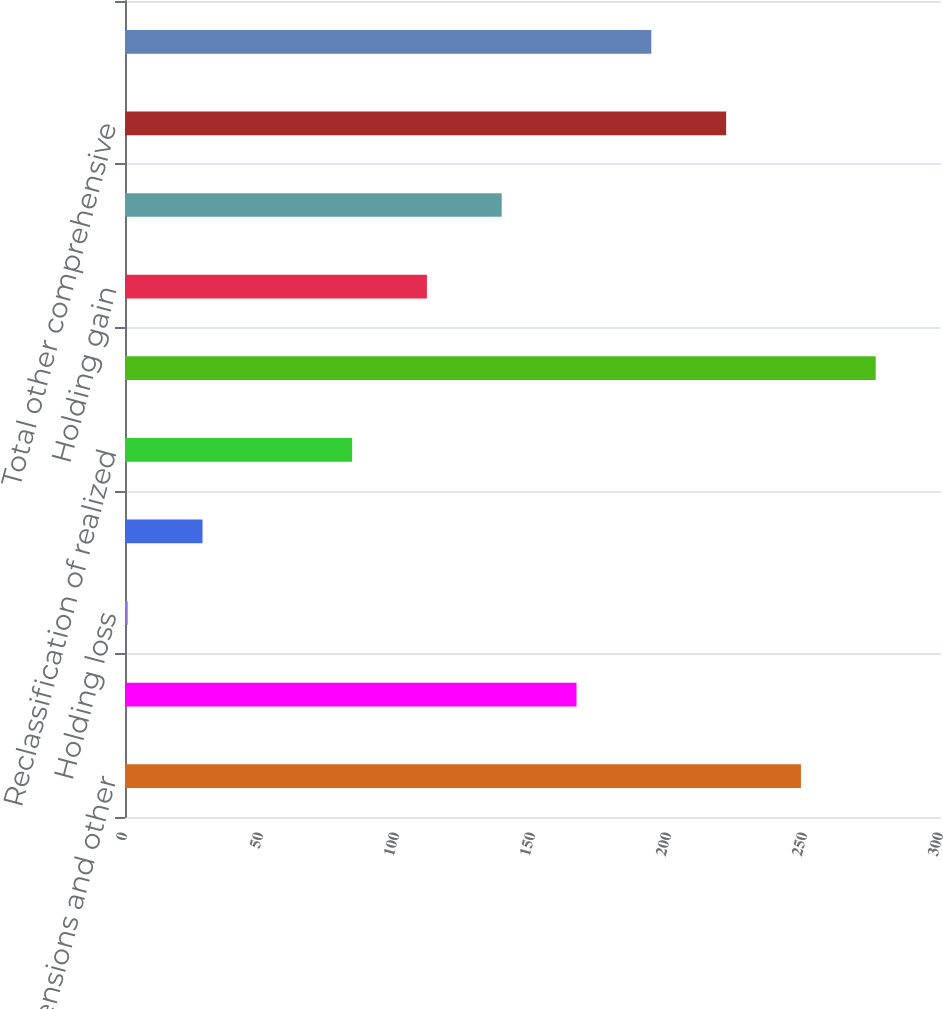<chart> <loc_0><loc_0><loc_500><loc_500><bar_chart><fcel>Change in pensions and other<fcel>Foreign currency translation<fcel>Holding loss<fcel>Net unrealized loss<fcel>Reclassification of realized<fcel>Total other comprehensive loss<fcel>Holding gain<fcel>Net unrealized gain<fcel>Total other comprehensive<fcel>Minimum pension liability<nl><fcel>248.5<fcel>166<fcel>1<fcel>28.5<fcel>83.5<fcel>276<fcel>111<fcel>138.5<fcel>221<fcel>193.5<nl></chart> 